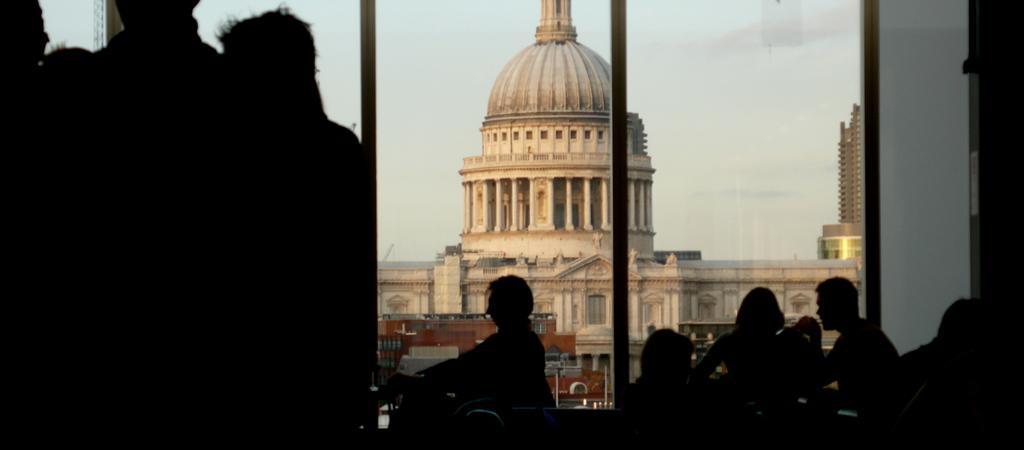Could you give a brief overview of what you see in this image? Here we can see few persons. In the background there are buildings and sky. 